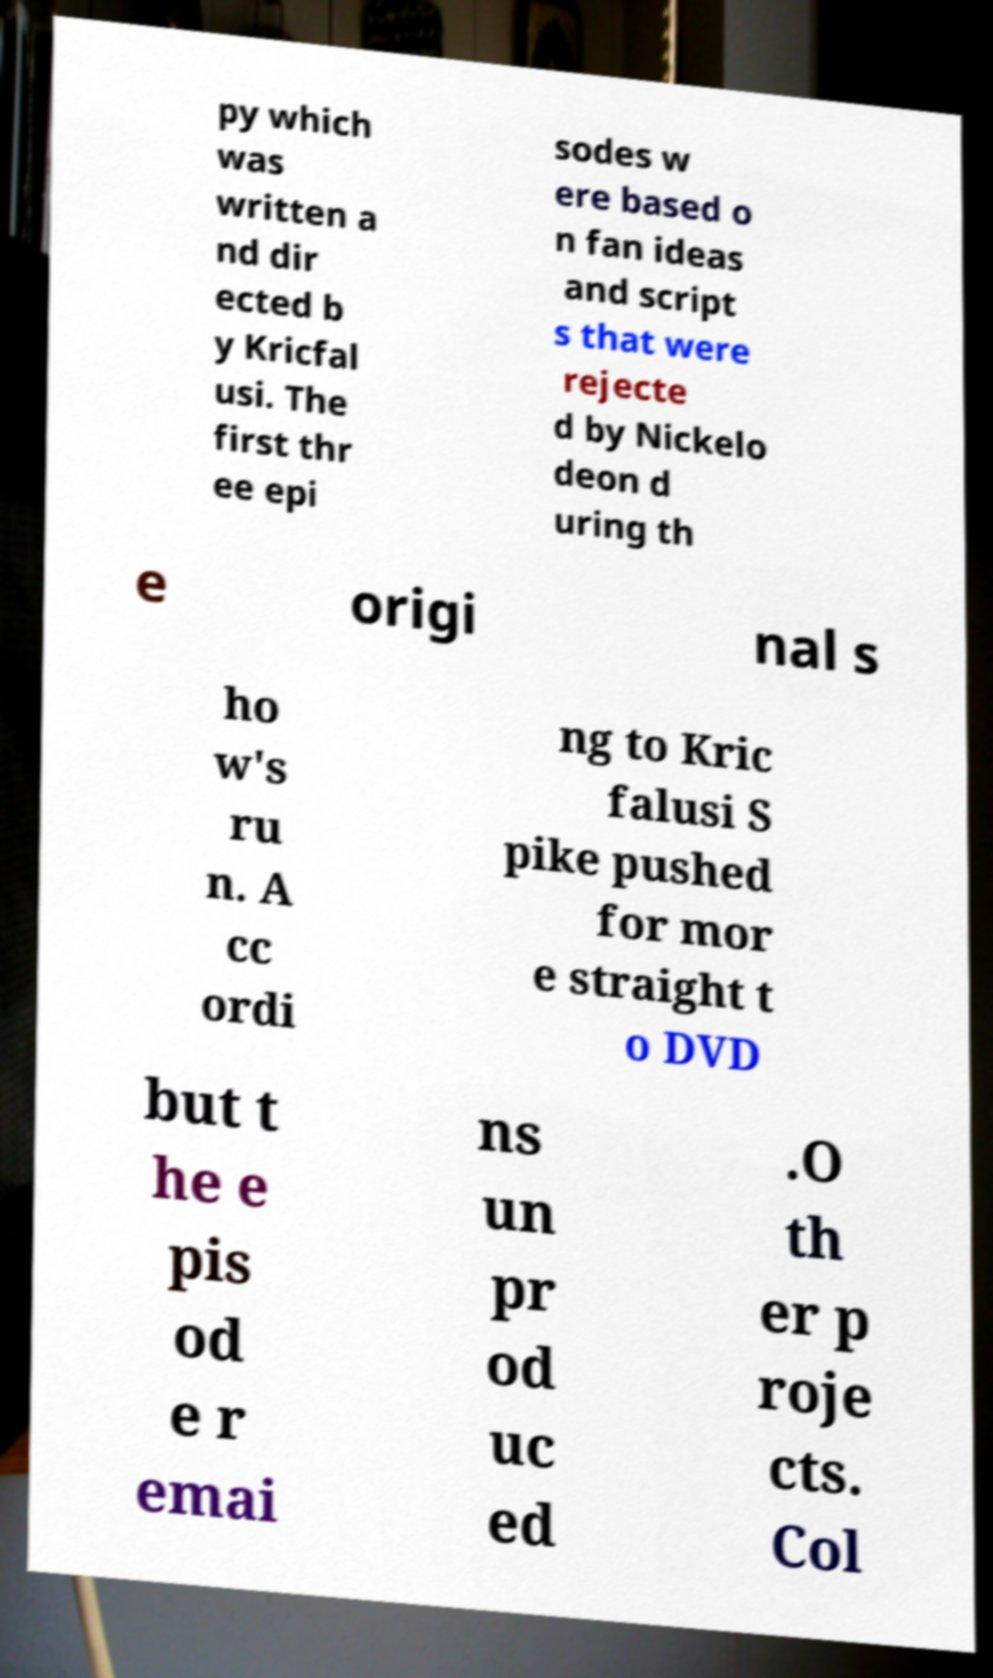Could you assist in decoding the text presented in this image and type it out clearly? py which was written a nd dir ected b y Kricfal usi. The first thr ee epi sodes w ere based o n fan ideas and script s that were rejecte d by Nickelo deon d uring th e origi nal s ho w's ru n. A cc ordi ng to Kric falusi S pike pushed for mor e straight t o DVD but t he e pis od e r emai ns un pr od uc ed .O th er p roje cts. Col 